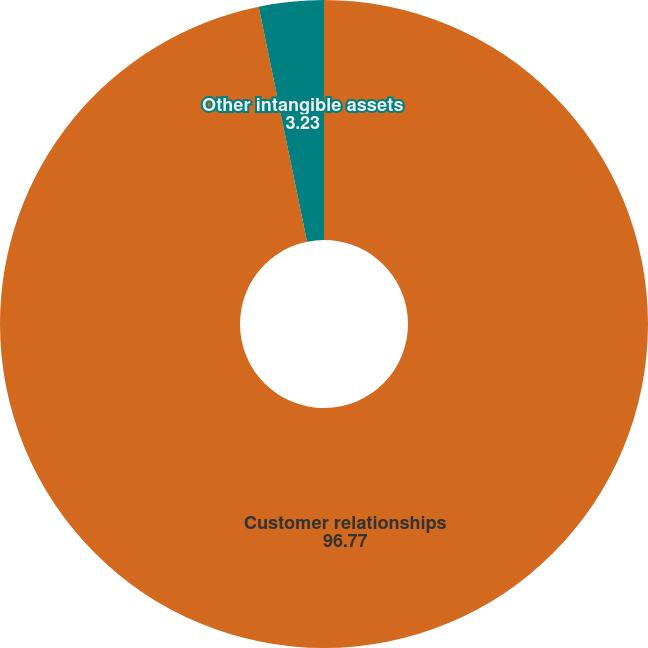Convert chart to OTSL. <chart><loc_0><loc_0><loc_500><loc_500><pie_chart><fcel>Customer relationships<fcel>Other intangible assets<nl><fcel>96.77%<fcel>3.23%<nl></chart> 